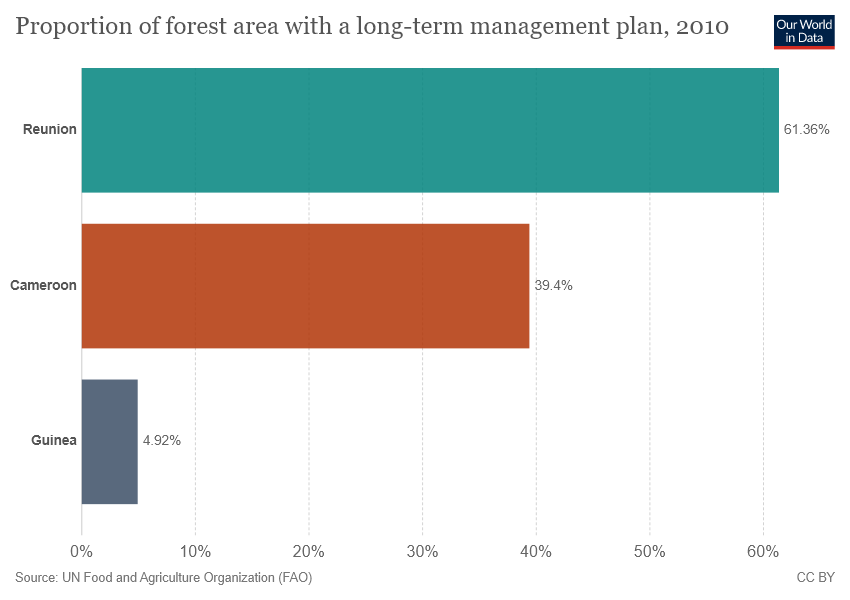Highlight a few significant elements in this photo. As of 2010, the combined forest area of Cameroon and Reunion, which has a long-term management plan, averaged 50.38%. In 2010, approximately 61.36% of Reunion was covered by forest areas that were managed under a long-term plan. 